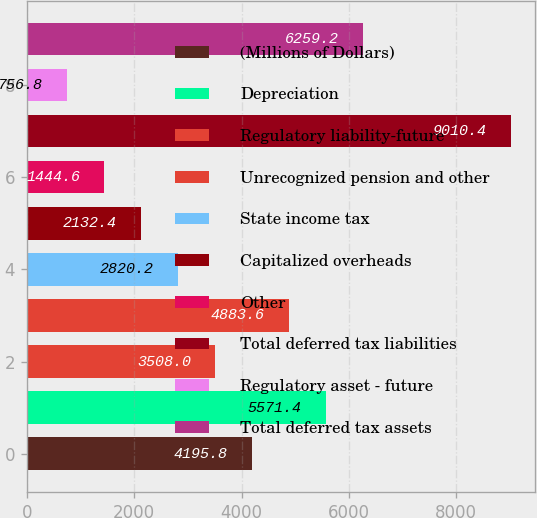Convert chart. <chart><loc_0><loc_0><loc_500><loc_500><bar_chart><fcel>(Millions of Dollars)<fcel>Depreciation<fcel>Regulatory liability-future<fcel>Unrecognized pension and other<fcel>State income tax<fcel>Capitalized overheads<fcel>Other<fcel>Total deferred tax liabilities<fcel>Regulatory asset - future<fcel>Total deferred tax assets<nl><fcel>4195.8<fcel>5571.4<fcel>3508<fcel>4883.6<fcel>2820.2<fcel>2132.4<fcel>1444.6<fcel>9010.4<fcel>756.8<fcel>6259.2<nl></chart> 